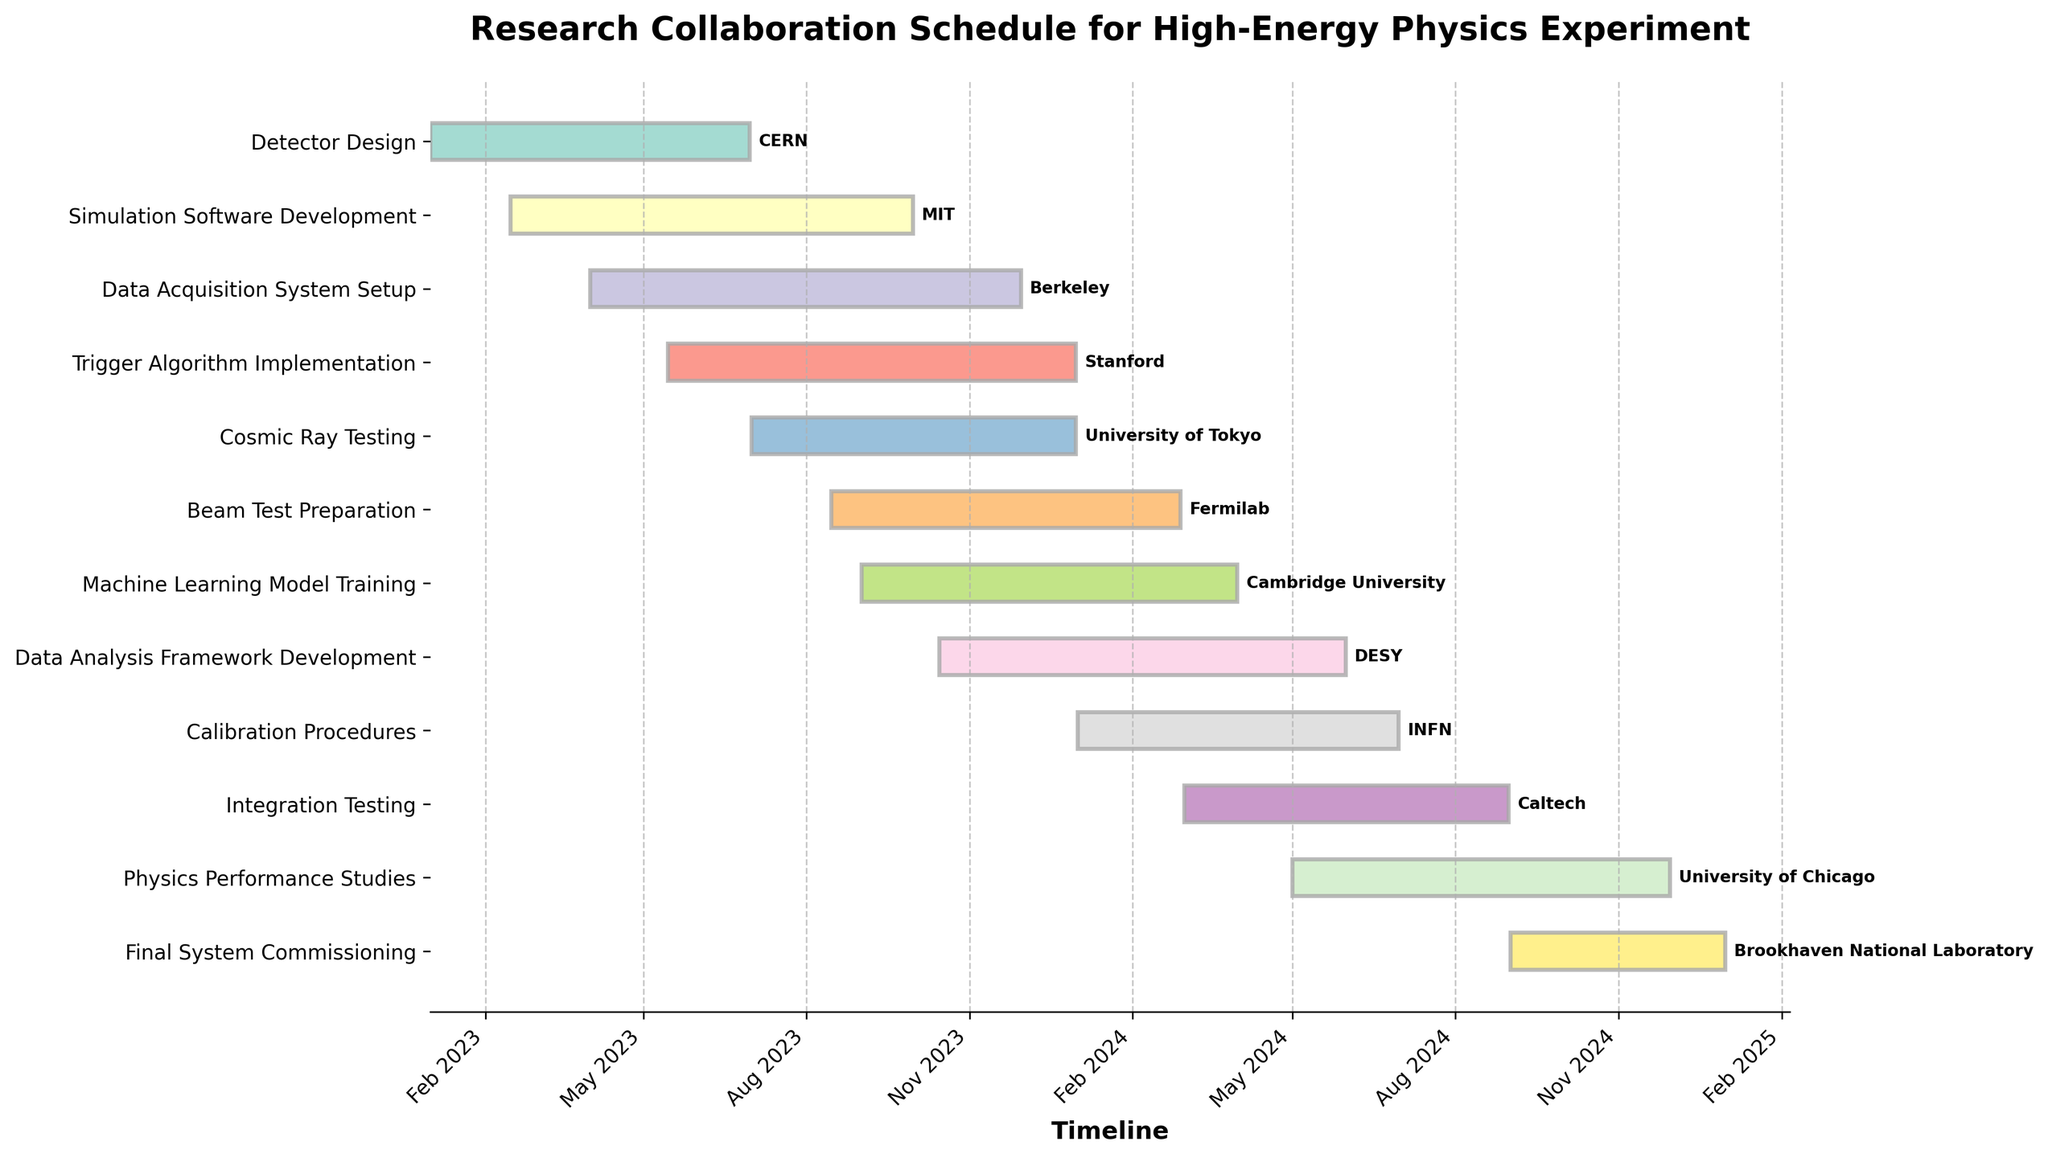What is the title of the figure? The title is usually found at the top of the figure. In this case, it is "Research Collaboration Schedule for High-Energy Physics Experiment".
Answer: Research Collaboration Schedule for High-Energy Physics Experiment Which institution is responsible for the task "Data Acquisition System Setup"? The task of "Data Acquisition System Setup" is labeled with its institution, which is "Berkeley".
Answer: Berkeley How many tasks are expected to finish by the end of 2023? From the Gantt Chart, the tasks finishing by the end of 2023 are "Detector Design", "Simulation Software Development", "Data Acquisition System Setup", "Trigger Algorithm Implementation", "Cosmic Ray Testing", "Beam Test Preparation", and the start of "Machine Learning Model Training". Count these tasks.
Answer: 6 When does the "Data Analysis Framework Development" task start and end? Look for the "Data Analysis Framework Development" task in the Gantt Chart and note its start and end dates. It starts on 2023-10-15 and ends on 2024-05-31.
Answer: 2023-10-15 to 2024-05-31 Which task spans the longest duration, and how long is it? Compare the durations of all tasks by assessing their lengths on the Gantt Chart. The "Integration Testing" task has one of the longest durations from 2024-03-01 to 2024-08-31. Calculate the number of days between these dates (end date - start date).
Answer: Integration Testing, 184 days Do any two tasks overlap completely in their timelines? Assess the timelines individually and compare for any tasks that share the same start and end dates entirely. None of the tasks completely overlap.
Answer: No Which task is the first to start, and which is the last to finish? Look at the earliest start date and the latest end date among all the tasks. The first task to start is "Detector Design" on 2023-01-01, and the last task to finish is "Final System Commissioning" on 2024-12-31.
Answer: Detector Design, Final System Commissioning Which two institutions have consecutive tasks without a break in between their timelines? Look for tasks that finish and start consecutively without any gap. For instance, "Beam Test Preparation" ends on 2024-02-28 and "Calibration Procedures" starts on 2024-01-01, with some overlap.
Answer: Fermilab and INFN What is the total duration of the "Cosmic Ray Testing" task, and how does it compare to the duration of the "Physics Performance Studies" task? Calculate the total duration for both tasks and compare. "Cosmic Ray Testing" runs from 2023-07-01 to 2023-12-31 (184 days) and "Physics Performance Studies" from 2024-05-01 to 2024-11-30 (214 days).
Answer: 184 days vs. 214 days 